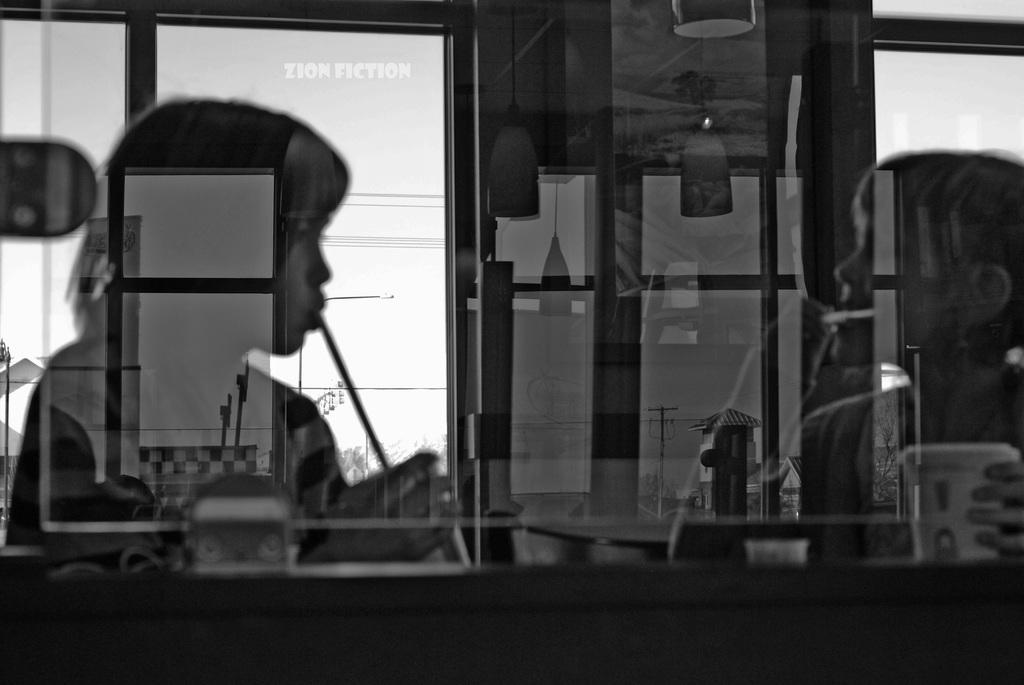What object is present in the image that can hold a liquid? There is a glass in the image. What can be seen inside the glass? Two persons are visible in the glass. What type of structures are present in the image? There are light poles in the image. What is the color scheme of the image? The image is in black and white. How many cars can be seen covered by a quilt in the image? There are no cars or quilts present in the image. 